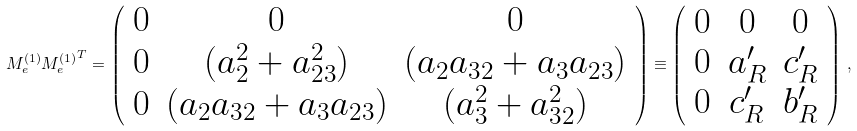Convert formula to latex. <formula><loc_0><loc_0><loc_500><loc_500>M ^ { ( 1 ) } _ { e } { M ^ { ( 1 ) } _ { e } } ^ { T } = \left ( \begin{array} { c c c } 0 & 0 & 0 \\ 0 & ( a _ { 2 } ^ { 2 } + a _ { 2 3 } ^ { 2 } ) & ( a _ { 2 } a _ { 3 2 } + a _ { 3 } a _ { 2 3 } ) \\ 0 & ( a _ { 2 } a _ { 3 2 } + a _ { 3 } a _ { 2 3 } ) & ( a _ { 3 } ^ { 2 } + a _ { 3 2 } ^ { 2 } ) \end{array} \right ) \equiv \left ( \begin{array} { c c c } 0 & 0 & 0 \\ 0 & a _ { R } ^ { \prime } & c _ { R } ^ { \prime } \\ 0 & c _ { R } ^ { \prime } & b _ { R } ^ { \prime } \end{array} \right ) \, ,</formula> 